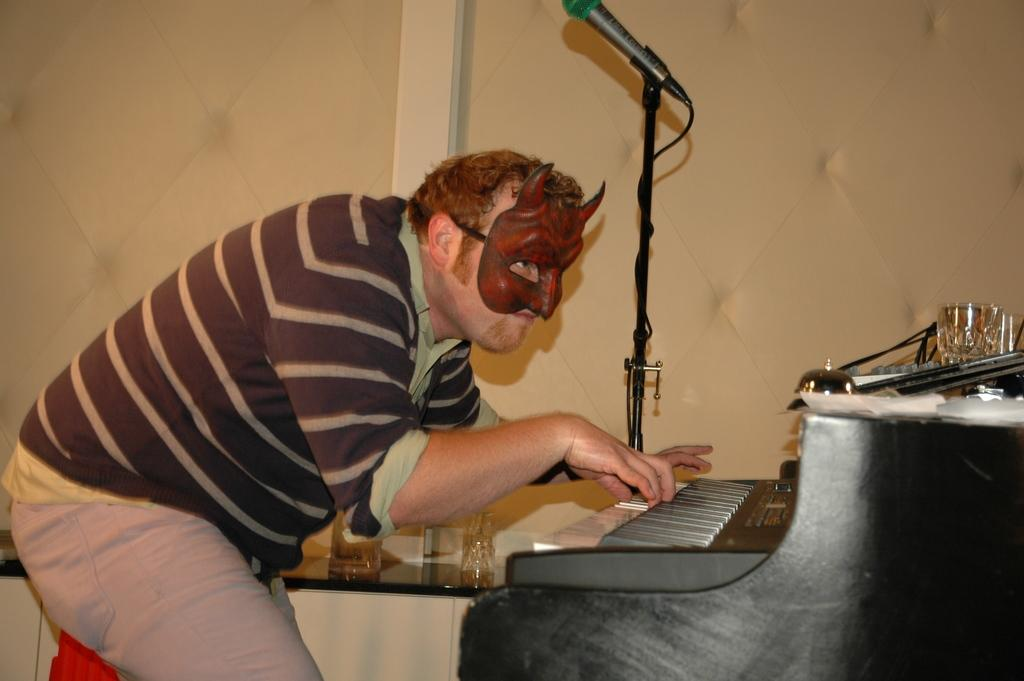What is the man in the picture doing? The man is playing the piano. What is the man wearing on his face? The man is wearing a mask. What is the man's posture in the picture? The man is standing. What object is beside the man? There is a microphone beside the man. What can be seen in the background of the picture? There is a wall in the background of the picture. What type of steel is used to make the collar in the image? There is no collar present in the image, and therefore no steel can be associated with it. 